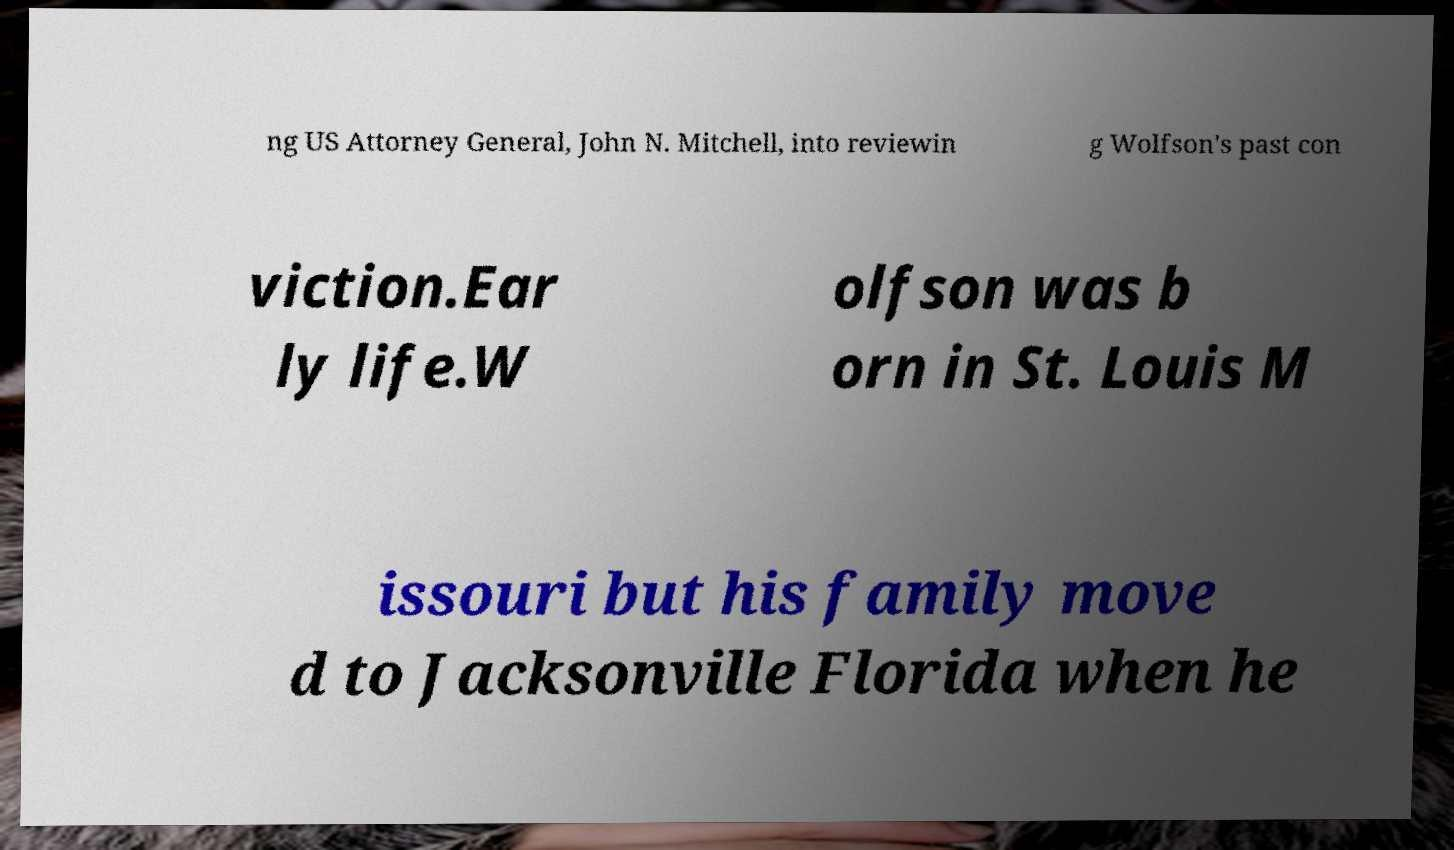What messages or text are displayed in this image? I need them in a readable, typed format. ng US Attorney General, John N. Mitchell, into reviewin g Wolfson's past con viction.Ear ly life.W olfson was b orn in St. Louis M issouri but his family move d to Jacksonville Florida when he 